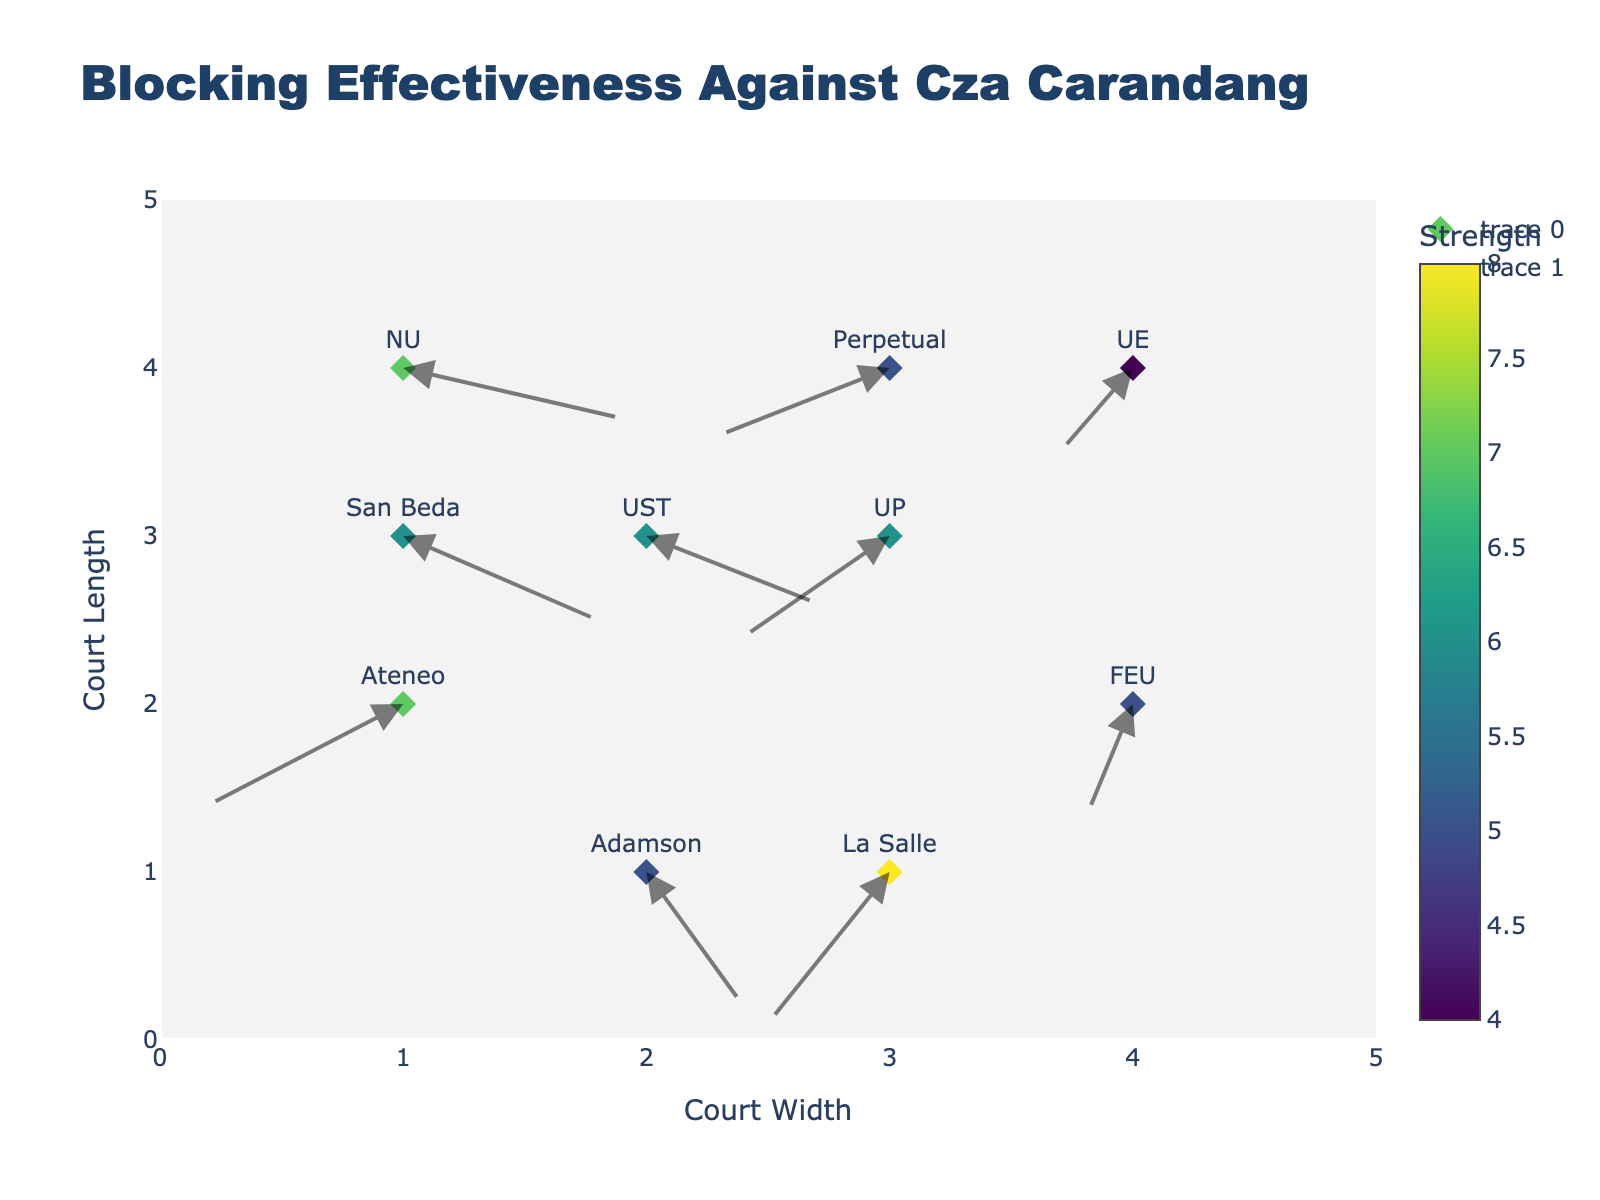What's the title of the figure? The title is usually placed at the top of the figure. This quiver plot has a title set at the top center.
Answer: Blocking Effectiveness Against Cza Carandang How many teams are represented in the plot? There are individual points plotted on the graph, each representing a different team. By counting them, we determine the number of teams.
Answer: 10 Which team displays the strongest defense against Cza Carandang's attacks? The color bar indicates the strength of defense, with colors closer to the top of the color scale representing higher strength. Find the team associated with the highest strength value.
Answer: La Salle Which team is positioned at coordinates (1, 2)? From the coordinates provided in the plot, check which team is marked at (1, 2) on the graph.
Answer: Ateneo What is the direction and strength of the blocking formation for NU? Locate NU on the plot. The arrow originating from the location of NU will indicate the direction, and the color code or numerical indicator gives the strength.
Answer: Direction: (0.9, -0.3), Strength: 7 Compare the blocking strength of Ateneo and FEU. Which one is stronger? By looking at the color bar, identify the strength values for both Ateneo and FEU and compare them.
Answer: Ateneo 